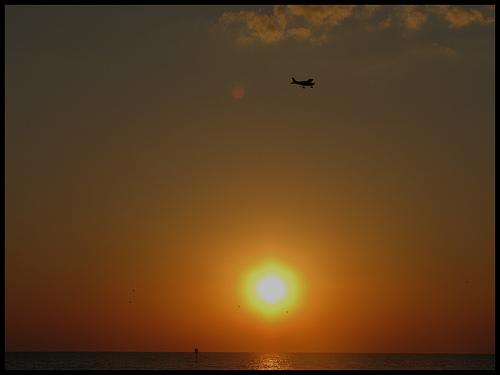Are there any people in the scene?
Keep it brief. No. Is this a romantic scene?
Give a very brief answer. Yes. Is there a sandy beach in the horizon?
Write a very short answer. No. What time is it?
Keep it brief. Sunset. The weather is sunny?
Short answer required. Yes. What else is seen in the sky?
Give a very brief answer. Plane. Is the light for the person to see with?
Concise answer only. No. Is the sun setting or rising?
Be succinct. Setting. What color is the sky?
Keep it brief. Orange. What type of plane is it?
Short answer required. Propeller. What direction is the airplane flying?
Be succinct. Right. 